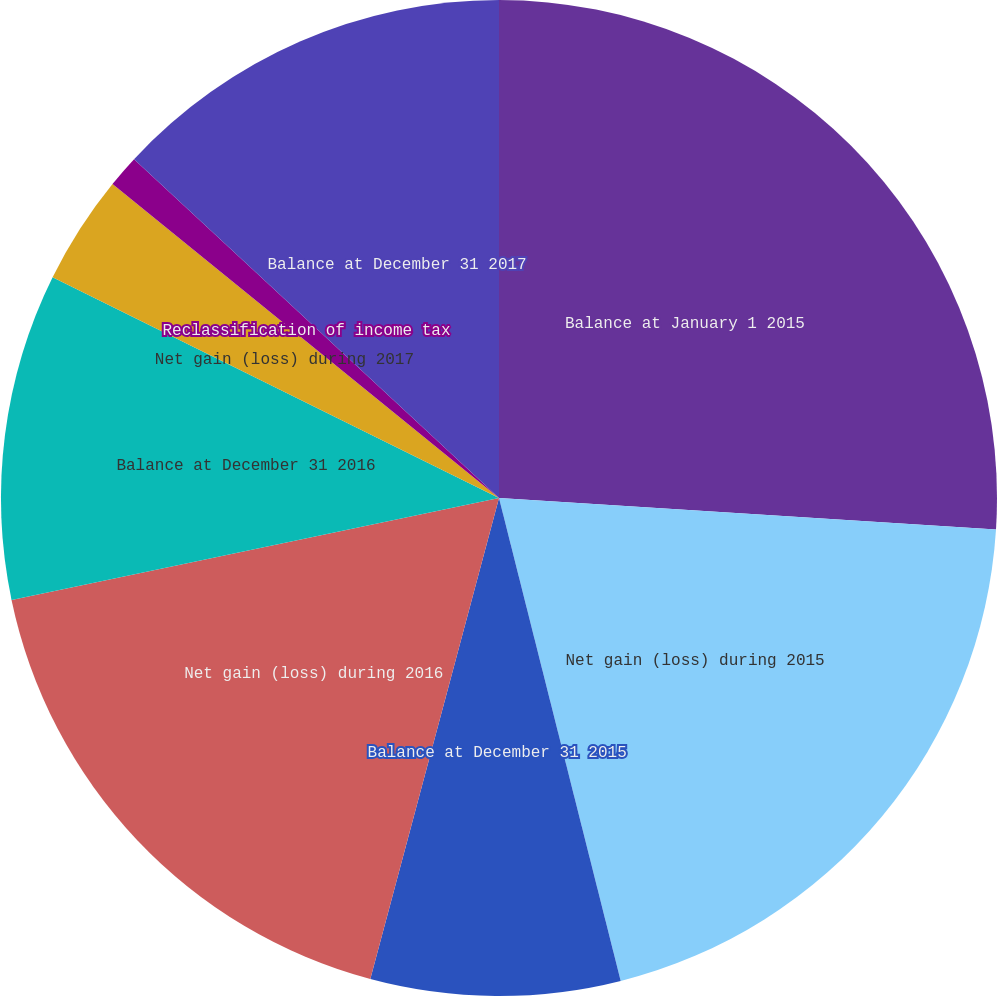<chart> <loc_0><loc_0><loc_500><loc_500><pie_chart><fcel>Balance at January 1 2015<fcel>Net gain (loss) during 2015<fcel>Balance at December 31 2015<fcel>Net gain (loss) during 2016<fcel>Balance at December 31 2016<fcel>Net gain (loss) during 2017<fcel>Reclassification of income tax<fcel>Balance at December 31 2017<nl><fcel>26.01%<fcel>20.06%<fcel>8.09%<fcel>17.56%<fcel>10.59%<fcel>3.55%<fcel>1.05%<fcel>13.09%<nl></chart> 